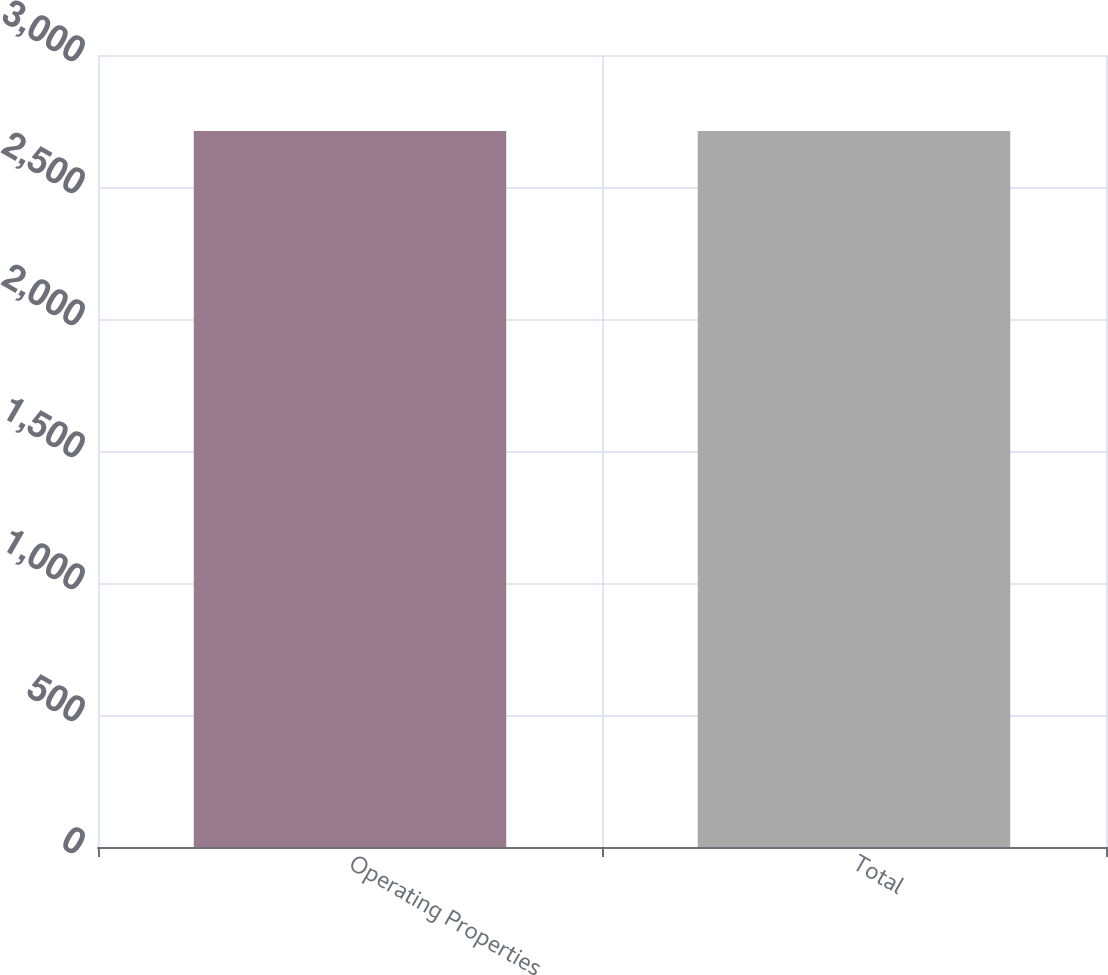Convert chart. <chart><loc_0><loc_0><loc_500><loc_500><bar_chart><fcel>Operating Properties<fcel>Total<nl><fcel>2712<fcel>2712.1<nl></chart> 